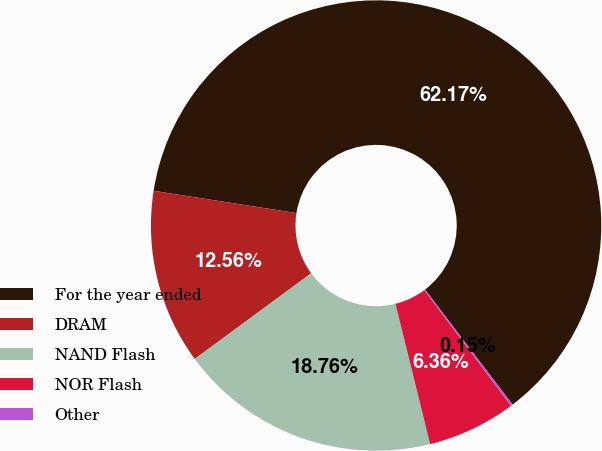Convert chart to OTSL. <chart><loc_0><loc_0><loc_500><loc_500><pie_chart><fcel>For the year ended<fcel>DRAM<fcel>NAND Flash<fcel>NOR Flash<fcel>Other<nl><fcel>62.17%<fcel>12.56%<fcel>18.76%<fcel>6.36%<fcel>0.15%<nl></chart> 